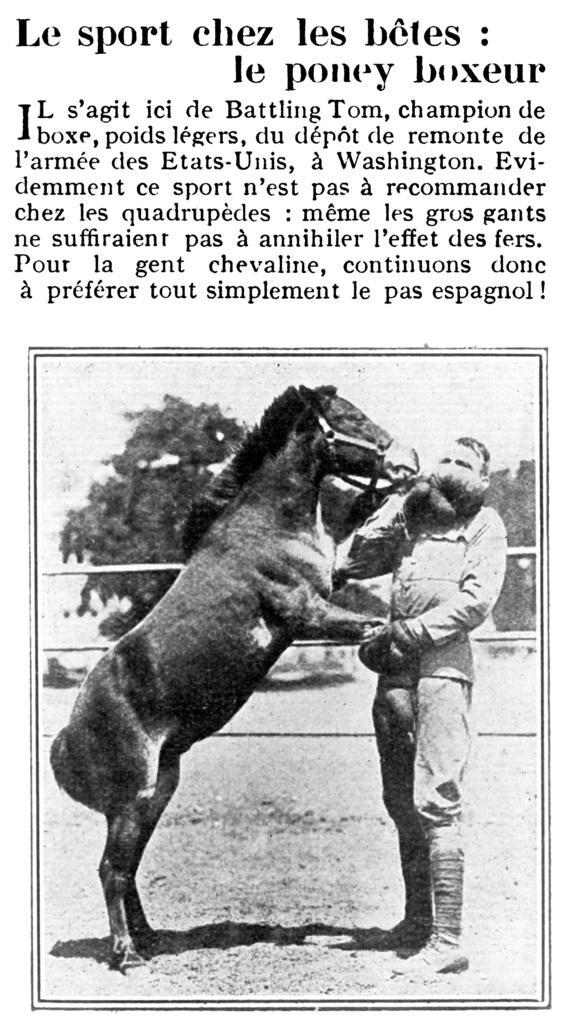In one or two sentences, can you explain what this image depicts? In this image, we can see an article. At the bottom of the image, there is a black and white picture. In this picture, we can see a person holding a horse on the ground. In the background, there are trees, rods and the sky. 